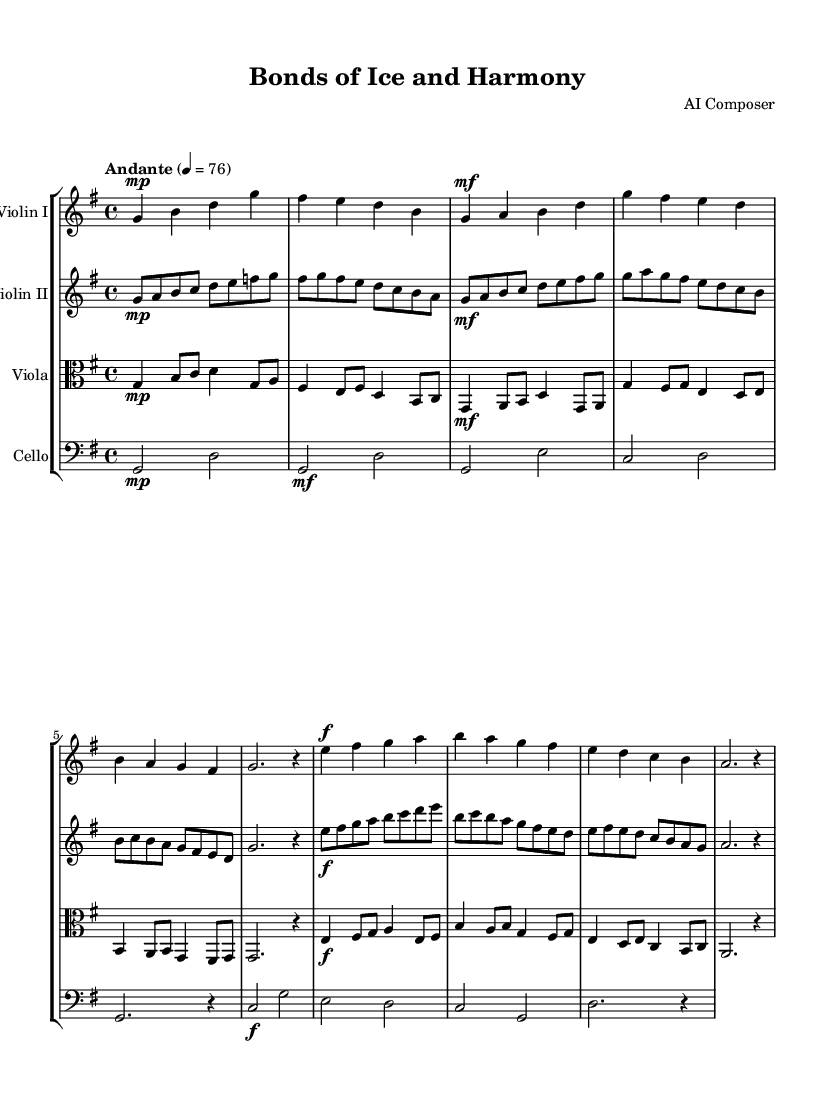What is the key signature of this music? The key signature shows one sharp, which indicates that the piece is in G major.
Answer: G major What is the time signature of the piece? The time signature is located at the beginning of the score, showing that it is 4/4, meaning there are four beats in each measure.
Answer: 4/4 What is the tempo marking for this piece? The tempo marking indicates that the music should be played at an Andante speed, which is typically a moderate pace.
Answer: Andante How many measures are in Theme A? By counting the highlighted sections labeled as Theme A in the score, it is noted that there are eight measures.
Answer: Eight What dynamic marking is used at the beginning of the piece? The music begins with a mezzo-piano dynamic marking, suggesting that it should be played moderately soft at the start.
Answer: Mezzo-piano Which instrument plays the introduction's first notes? The introduction's first notes are played by the cello, indicated by the clef and musical notation at the start of the score.
Answer: Cello What is the texture of the music as represented in this score? The score features a string quartet, indicating a rich texture with multiple layers. Each instrument has its own line, contributing to the harmonies, typical of a Romantic string arrangement.
Answer: String quartet 